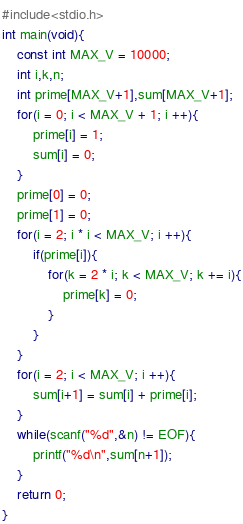<code> <loc_0><loc_0><loc_500><loc_500><_C_>#include<stdio.h>
int main(void){
    const int MAX_V = 10000;
    int i,k,n;
    int prime[MAX_V+1],sum[MAX_V+1];
    for(i = 0; i < MAX_V + 1; i ++){
        prime[i] = 1;
        sum[i] = 0;
    }
    prime[0] = 0;
    prime[1] = 0;
    for(i = 2; i * i < MAX_V; i ++){
        if(prime[i]){
            for(k = 2 * i; k < MAX_V; k += i){
                prime[k] = 0;
            }
        }
    }
    for(i = 2; i < MAX_V; i ++){
        sum[i+1] = sum[i] + prime[i];
    }
    while(scanf("%d",&n) != EOF){
        printf("%d\n",sum[n+1]);
    }
    return 0;
}</code> 